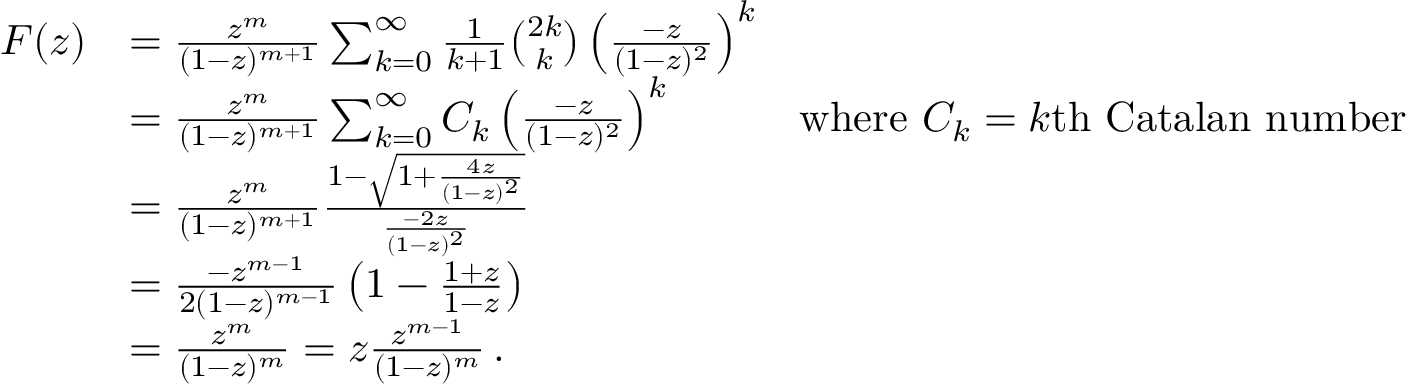Convert formula to latex. <formula><loc_0><loc_0><loc_500><loc_500>{ \begin{array} { r l r } { F ( z ) } & { = { \frac { z ^ { m } } { ( 1 - z ) ^ { m + 1 } } } \sum _ { k = 0 } ^ { \infty } { { \frac { 1 } { k + 1 } } { \binom { 2 k } { k } } \left ( { \frac { - z } { ( 1 - z ) ^ { 2 } } } \right ) ^ { k } } } \\ & { = { \frac { z ^ { m } } { ( 1 - z ) ^ { m + 1 } } } \sum _ { k = 0 } ^ { \infty } { C _ { k } \left ( { \frac { - z } { ( 1 - z ) ^ { 2 } } } \right ) ^ { k } } } & { { w h e r e } C _ { k } = k { t h C a t a l a n n u m b e r } } \\ & { = { \frac { z ^ { m } } { ( 1 - z ) ^ { m + 1 } } } { \frac { 1 - { \sqrt { 1 + { \frac { 4 z } { ( 1 - z ) ^ { 2 } } } } } } { \frac { - 2 z } { ( 1 - z ) ^ { 2 } } } } } \\ & { = { \frac { - z ^ { m - 1 } } { 2 ( 1 - z ) ^ { m - 1 } } } \left ( 1 - { \frac { 1 + z } { 1 - z } } \right ) } \\ & { = { \frac { z ^ { m } } { ( 1 - z ) ^ { m } } } = z { \frac { z ^ { m - 1 } } { ( 1 - z ) ^ { m } } } \, . } \end{array} }</formula> 